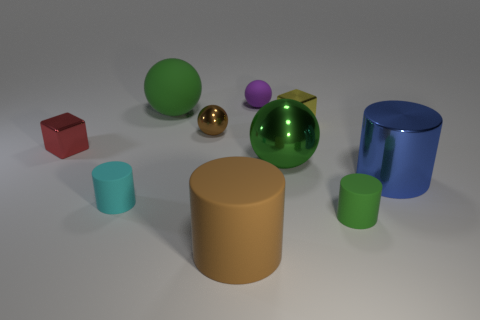What number of brown things are the same size as the green matte sphere?
Your answer should be compact. 1. There is a big green thing behind the tiny brown metallic thing; how many tiny matte cylinders are behind it?
Offer a terse response. 0. Do the big green ball in front of the tiny yellow thing and the small red object have the same material?
Ensure brevity in your answer.  Yes. Is the material of the big green object behind the red metal thing the same as the big cylinder that is on the left side of the green metal ball?
Provide a short and direct response. Yes. Is the number of yellow cubes that are right of the green matte ball greater than the number of small gray cylinders?
Your response must be concise. Yes. There is a small shiny block left of the small metallic block that is behind the red metallic block; what is its color?
Offer a terse response. Red. There is a yellow object that is the same size as the red metal object; what is its shape?
Your answer should be compact. Cube. There is a big object that is the same color as the large rubber sphere; what shape is it?
Make the answer very short. Sphere. Are there an equal number of cubes that are on the right side of the green metal object and small balls?
Provide a short and direct response. No. The large cylinder on the right side of the sphere that is in front of the object to the left of the tiny cyan cylinder is made of what material?
Provide a short and direct response. Metal. 